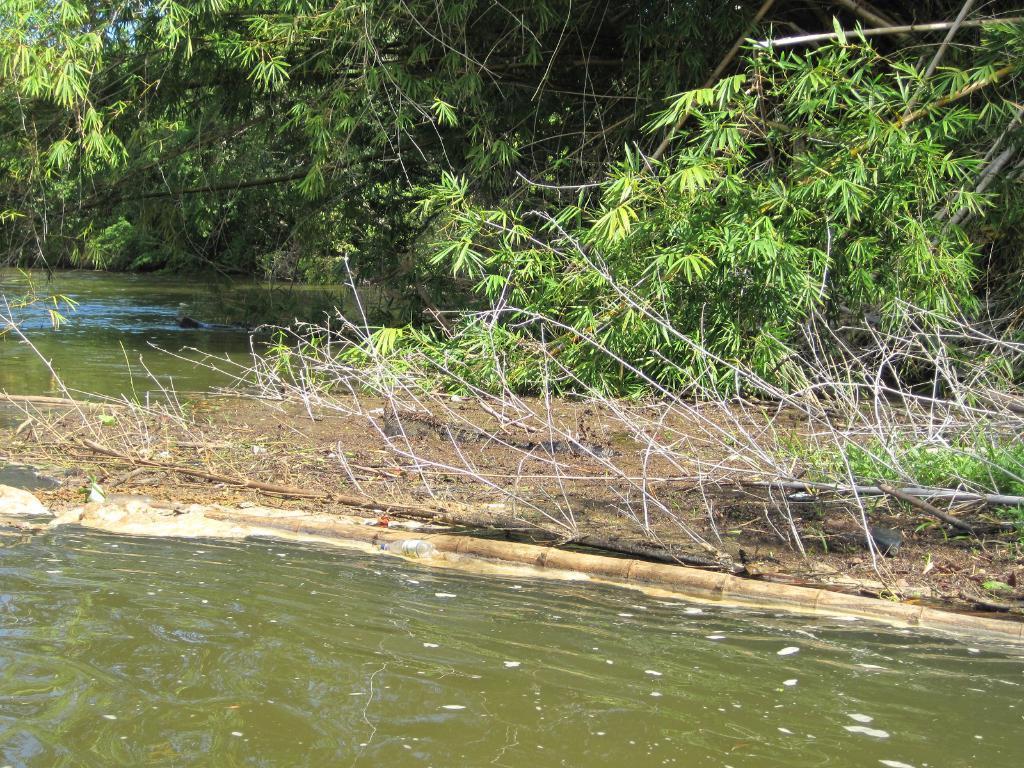Can you describe this image briefly? In this image we can see a group of trees and in the foreground we can see water 